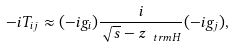Convert formula to latex. <formula><loc_0><loc_0><loc_500><loc_500>- i T _ { i j } \approx ( - i g _ { i } ) \frac { i } { \sqrt { s } - z _ { \ t r m { H } } } ( - i g _ { j } ) ,</formula> 